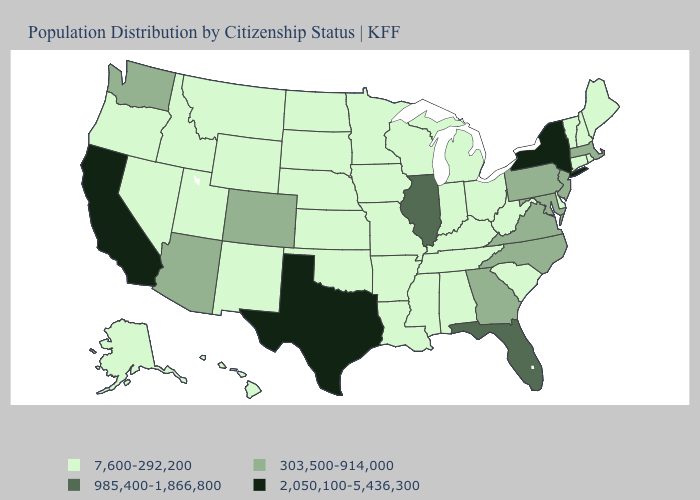Name the states that have a value in the range 985,400-1,866,800?
Short answer required. Florida, Illinois. Among the states that border Idaho , does Washington have the highest value?
Answer briefly. Yes. Which states hav the highest value in the South?
Quick response, please. Texas. What is the value of New Mexico?
Give a very brief answer. 7,600-292,200. What is the value of Arizona?
Keep it brief. 303,500-914,000. What is the value of Washington?
Answer briefly. 303,500-914,000. Which states have the highest value in the USA?
Concise answer only. California, New York, Texas. How many symbols are there in the legend?
Give a very brief answer. 4. Does New Jersey have the lowest value in the USA?
Quick response, please. No. What is the value of Wyoming?
Answer briefly. 7,600-292,200. What is the value of Virginia?
Concise answer only. 303,500-914,000. Name the states that have a value in the range 985,400-1,866,800?
Write a very short answer. Florida, Illinois. Does the first symbol in the legend represent the smallest category?
Be succinct. Yes. Which states hav the highest value in the South?
Write a very short answer. Texas. What is the value of North Dakota?
Keep it brief. 7,600-292,200. 